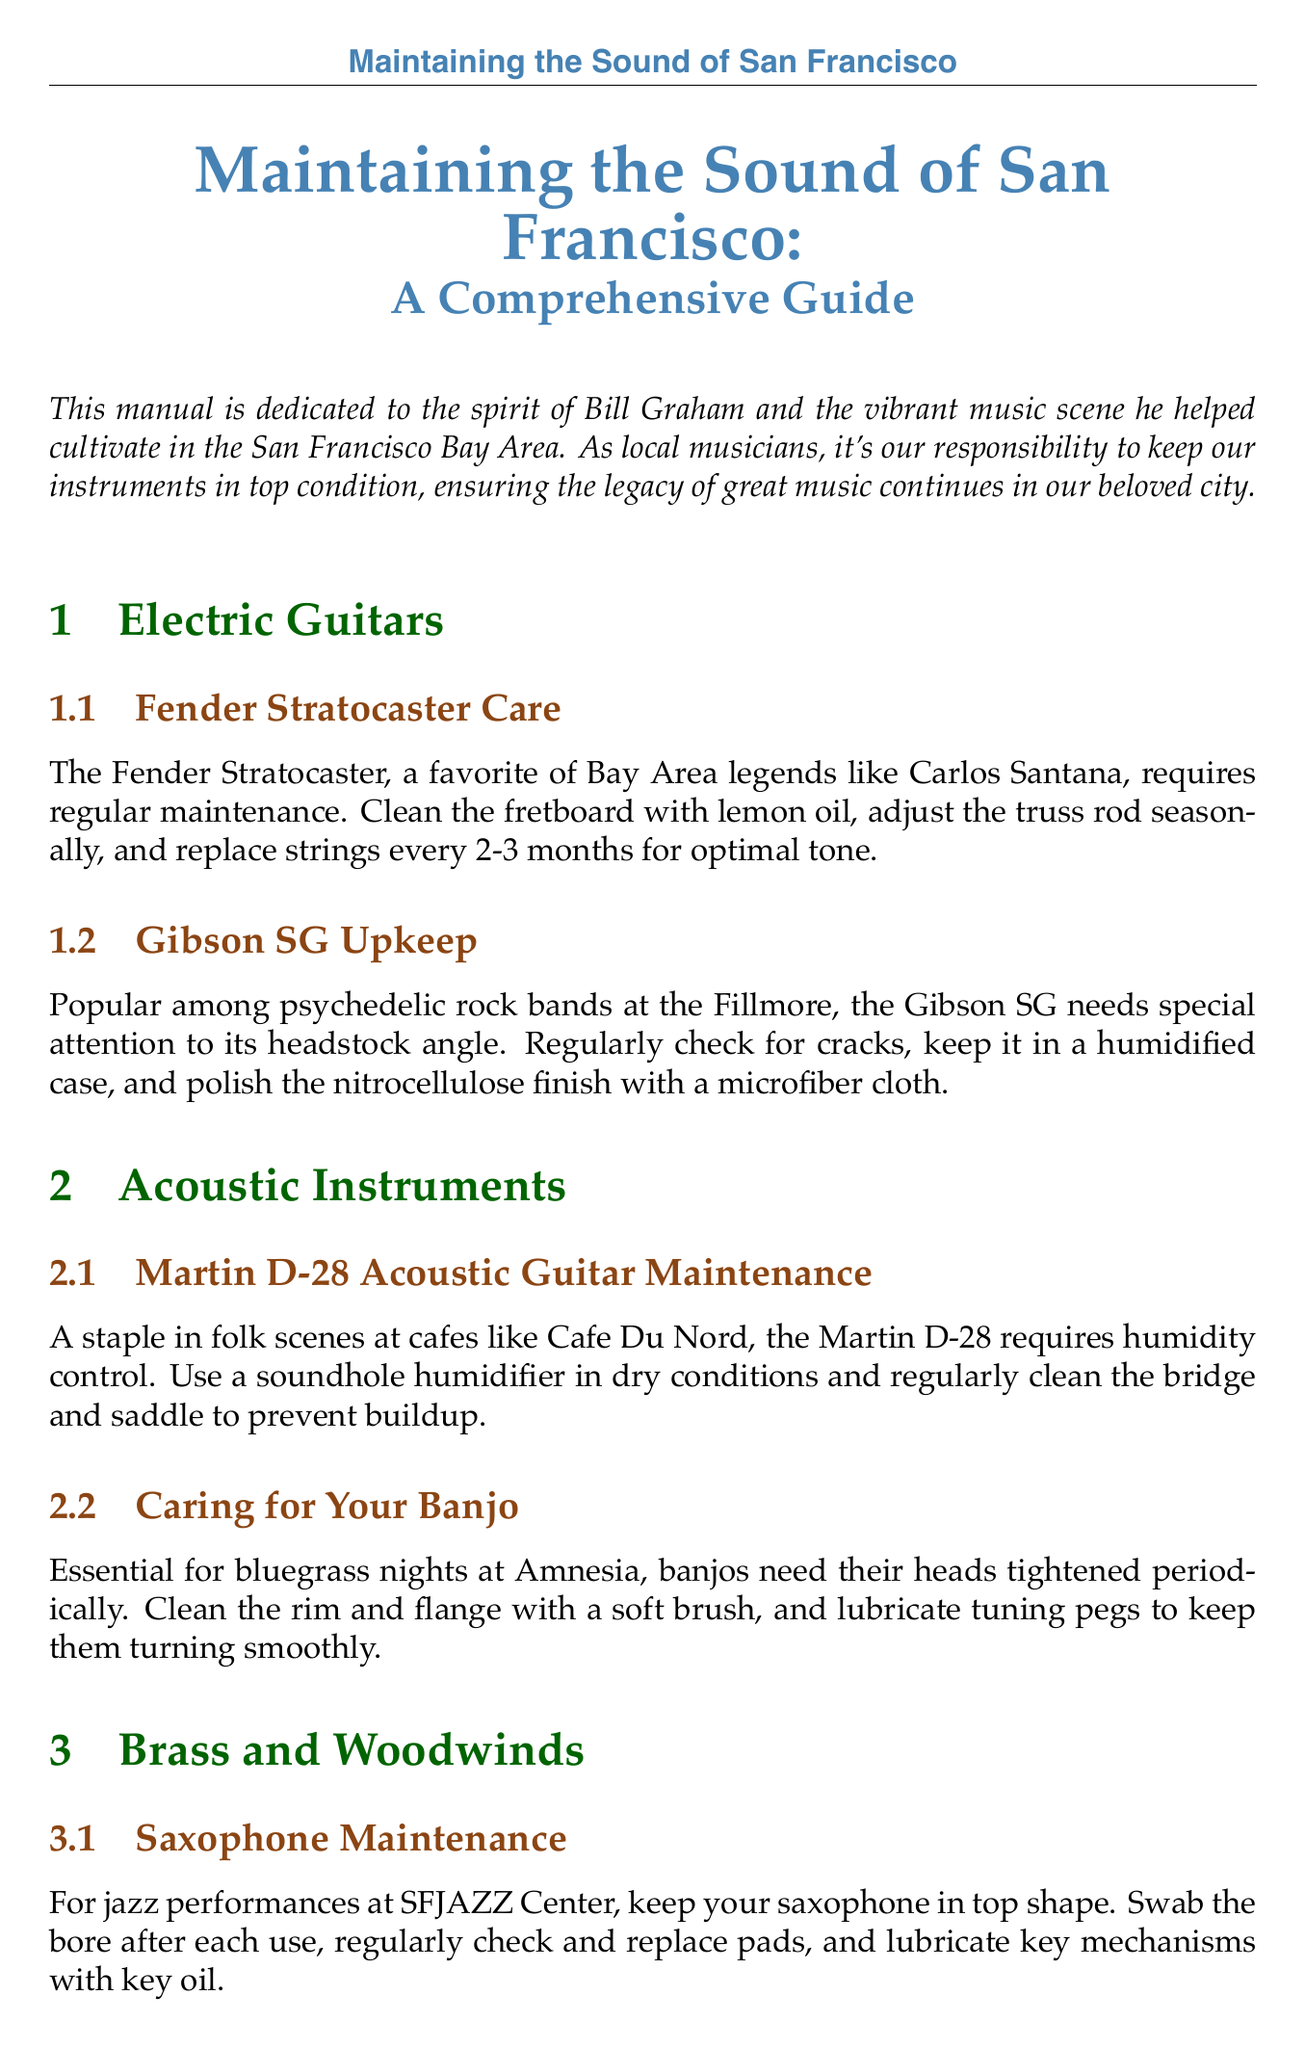what is the title of the manual? The title of the manual is explicitly stated at the beginning of the document under the introduction section.
Answer: Maintaining the Sound of San Francisco: A Comprehensive Guide who is the manual dedicated to? The document mentions that it is dedicated to a significant figure in the music scene, providing insight into its intention.
Answer: Bill Graham how often should strings be replaced on a Fender Stratocaster? The manual specifies maintenance recommendations, including the frequency of string replacement for optimal performance.
Answer: every 2-3 months what is used to clean the bridge and saddle of the Martin D-28? The cleaning requirements for this popular acoustic guitar are detailed in the acoustic instruments section.
Answer: regularly clean what type of oil is used to lubricate saxophone mechanisms? The maintenance of the saxophone includes specific recommendations for lubrication, indicating the correct type of oil.
Answer: key oil how often should trumpet valves be oiled? The document provides guidelines on regular maintenance to ensure proper functioning of the trumpet.
Answer: regularly which amplifier requires tube replacement every 1-2 years? This detail can be found in the section that discusses the care of various amplifiers and sound systems.
Answer: Fender Twin Reverb what should be used to remove dust from keys and knobs on a Nord Stage 3? The maintenance section for keyboards offers specific instructions for cleaning the Nord Stage 3.
Answer: compressed air what is needed for humidity control of the Martin D-28? The document outlines specific needs for maintaining this acoustic guitar, focusing on humidity levels.
Answer: soundhole humidifier 